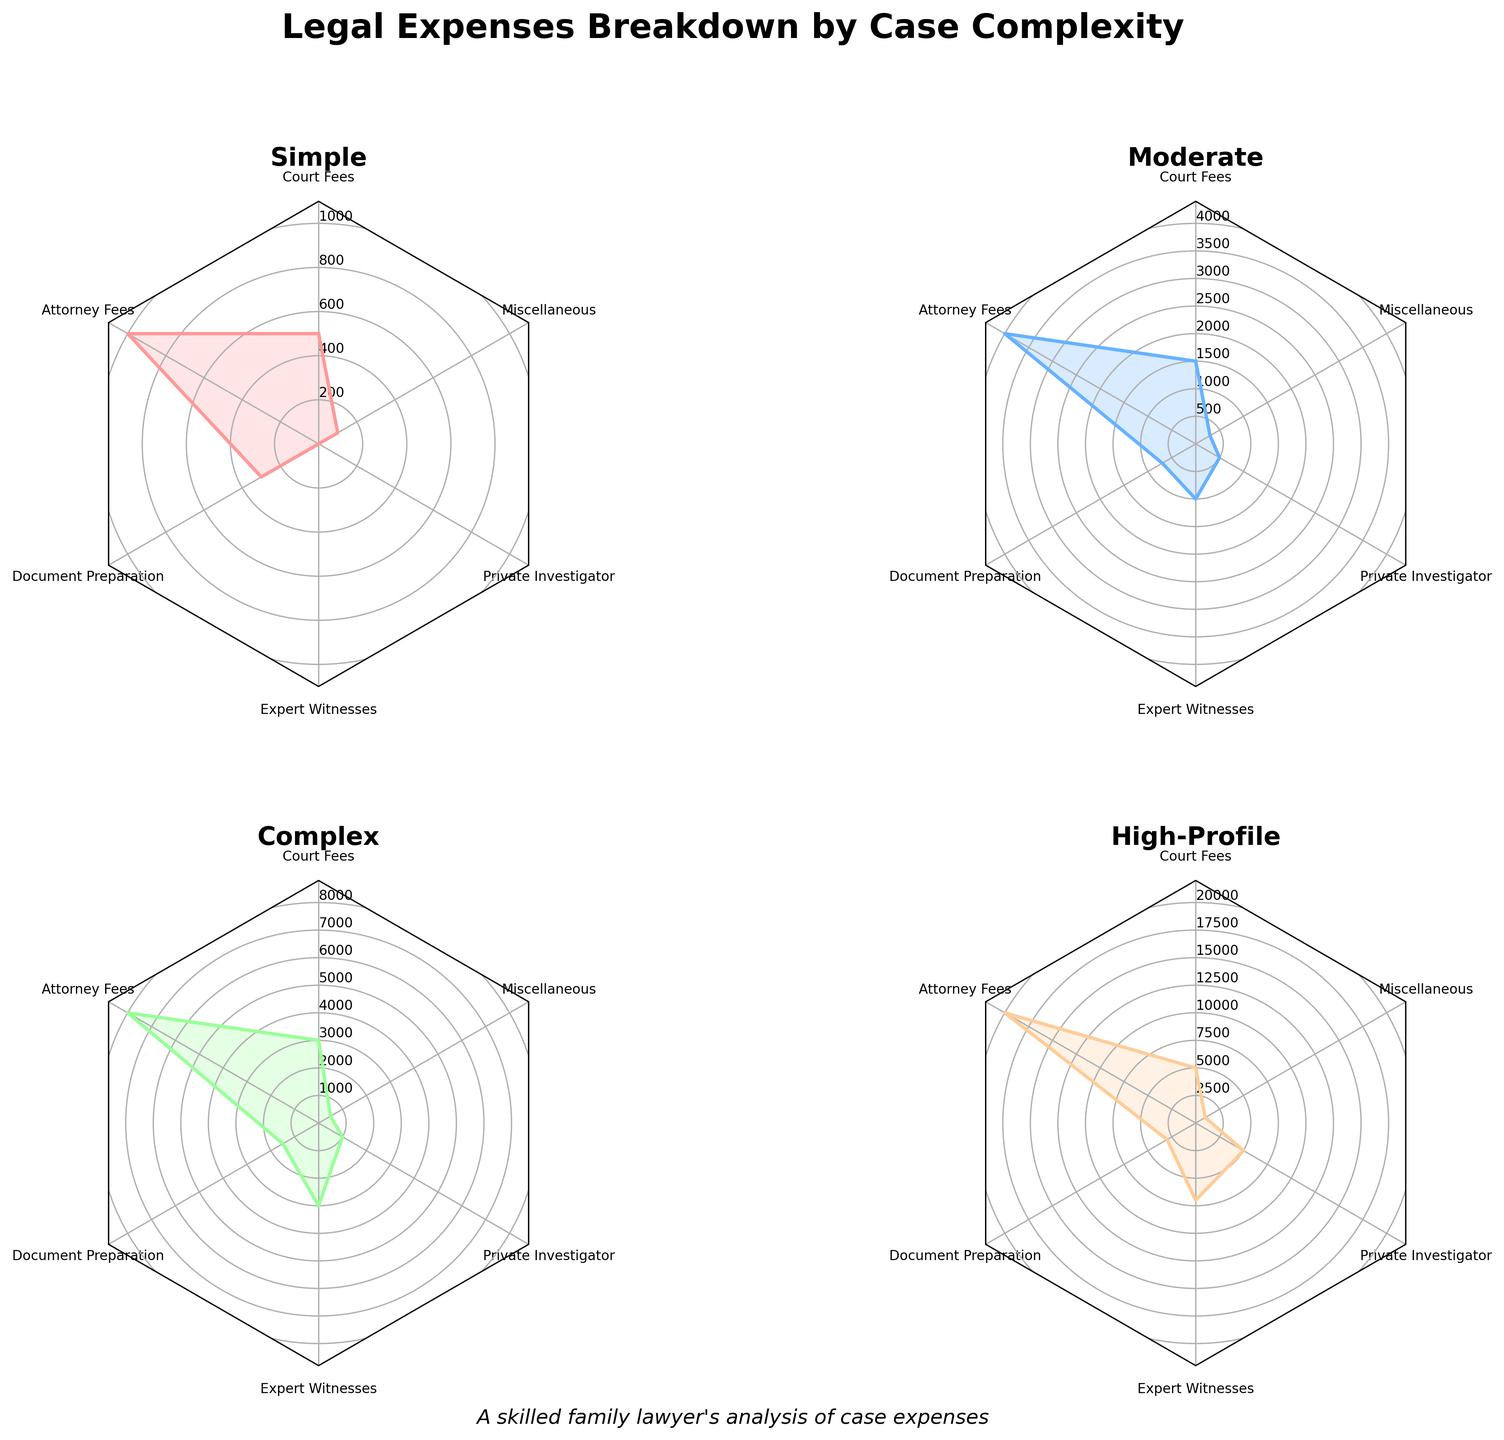Which case complexity has the highest attorney fees? The highest attorney fees can be identified by checking the peak value in the "Attorney Fees" section of each radar chart segment. The segment that stretches the most in this direction represents the highest cost. In this case, the High-Profile chart has the peak value.
Answer: High-Profile How do document preparation fees compare between simple and complex cases? Look at the segment that represents "Document Preparation" in both the Simple and Complex radar charts. By comparing their lengths, the radar chart shows that Complex cases have a higher value than Simple cases.
Answer: Complex cases have higher fees What is the total cost for moderate cases? To find the total, check the data point labeled "Moderate" on each radar chart and add them up. The total for Moderate cases is given as $8,000.
Answer: $8,000 Which type of expense is zero in Simple cases? On the Simple case radar chart, identify which category's value is zero. The Expert Witnesses and Private Investigator values are zero.
Answer: Expert Witnesses and Private Investigator Do high-profile cases have the highest cost across all categories? By examining the outer edges of the High-Profile radar chart, you can see that it touches the highest values for each category, indicating the highest cost.
Answer: Yes Which case type incurs the least cost for miscellaneous expenses? Check the radar chart section labeled "Miscellaneous" for each case type, and identify which one has the shortest segment. The Simple case has the least cost.
Answer: Simple Is there a noticeable difference in private investigator costs between moderate and high-profile cases? Compare the radar chart section representing "Private Investigator" costs for Moderate and High-Profile cases. High-Profile cases have significantly higher costs.
Answer: Yes What is the most significant expense for complex cases? On the Complex case radar chart, identify which segment extends the furthest from the center. Attorney Fees is the most extended segment, indicating the highest expense.
Answer: Attorney Fees How do court fees vary from simple to high-profile cases? Examine the section labeled "Court Fees" on each radar chart and describe how the value increases from Simple to High-Profile cases. The value increases progressively from 500 for Simple, 1500 for Moderate, 3000 for Complex, to 5000 for High-Profile cases.
Answer: Incrementally higher from Simple to High-Profile 